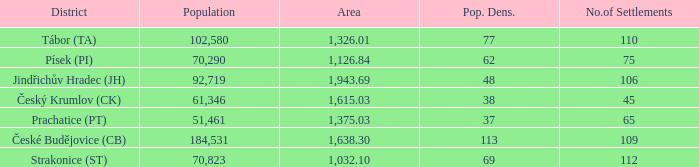How many settlements are in český krumlov (ck) with a population density higher than 38? None. 